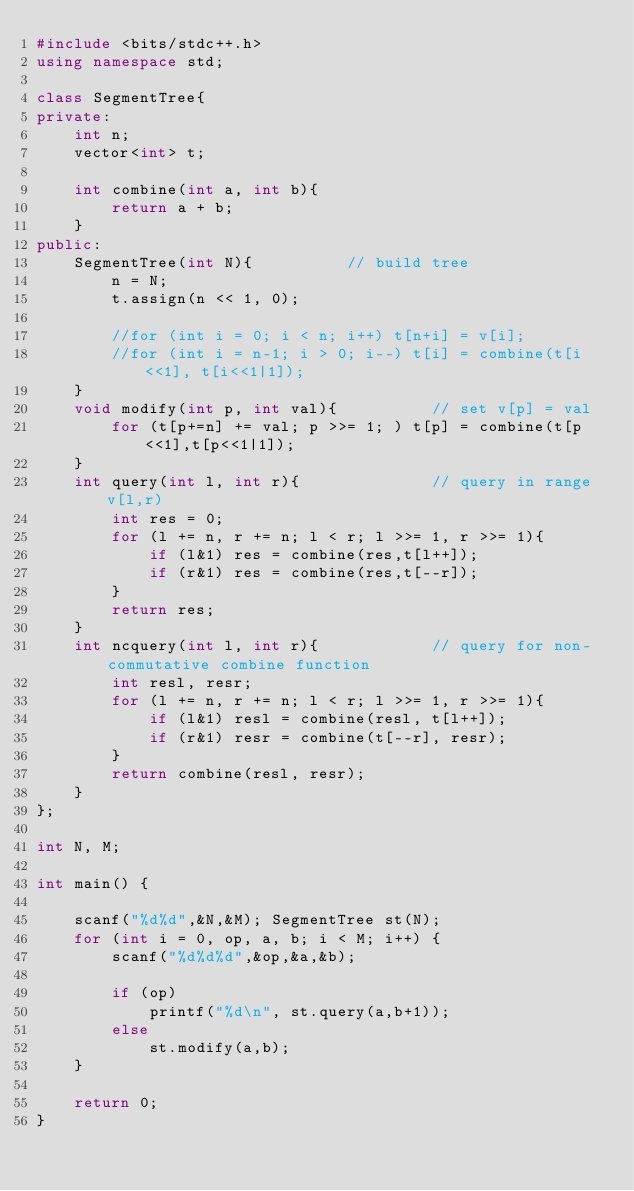Convert code to text. <code><loc_0><loc_0><loc_500><loc_500><_C++_>#include <bits/stdc++.h>
using namespace std;

class SegmentTree{
private:
    int n;
    vector<int> t;
    
    int combine(int a, int b){
        return a + b;
    }
public:
    SegmentTree(int N){          // build tree
        n = N;
        t.assign(n << 1, 0);
        
        //for (int i = 0; i < n; i++) t[n+i] = v[i];
        //for (int i = n-1; i > 0; i--) t[i] = combine(t[i<<1], t[i<<1|1]);
    }
    void modify(int p, int val){          // set v[p] = val
        for (t[p+=n] += val; p >>= 1; ) t[p] = combine(t[p<<1],t[p<<1|1]);
    }
    int query(int l, int r){              // query in range v[l,r)
        int res = 0;
        for (l += n, r += n; l < r; l >>= 1, r >>= 1){
            if (l&1) res = combine(res,t[l++]);
            if (r&1) res = combine(res,t[--r]);
        }
        return res;
    }
    int ncquery(int l, int r){            // query for non-commutative combine function
        int resl, resr;
        for (l += n, r += n; l < r; l >>= 1, r >>= 1){
            if (l&1) resl = combine(resl, t[l++]);
            if (r&1) resr = combine(t[--r], resr);
        }
        return combine(resl, resr);
    }
};

int N, M;

int main() {

    scanf("%d%d",&N,&M); SegmentTree st(N);
    for (int i = 0, op, a, b; i < M; i++) {
        scanf("%d%d%d",&op,&a,&b);

        if (op)
            printf("%d\n", st.query(a,b+1));
        else
            st.modify(a,b);
    }

    return 0;
}</code> 